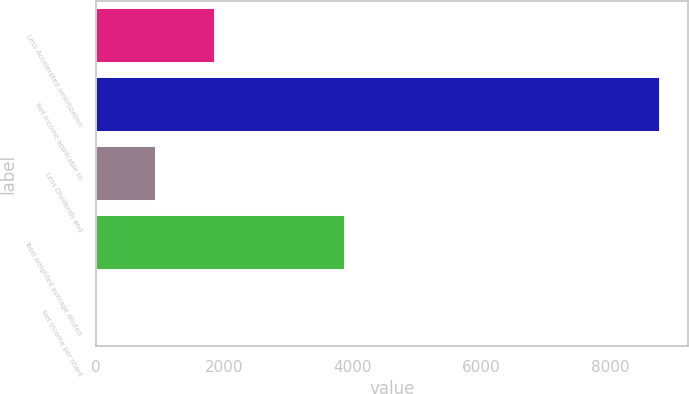<chart> <loc_0><loc_0><loc_500><loc_500><bar_chart><fcel>Less Accelerated amortization<fcel>Net income applicable to<fcel>Less Dividends and<fcel>Total weighted average diluted<fcel>Net income per share<nl><fcel>1859.6<fcel>8774<fcel>930.93<fcel>3879.7<fcel>2.26<nl></chart> 